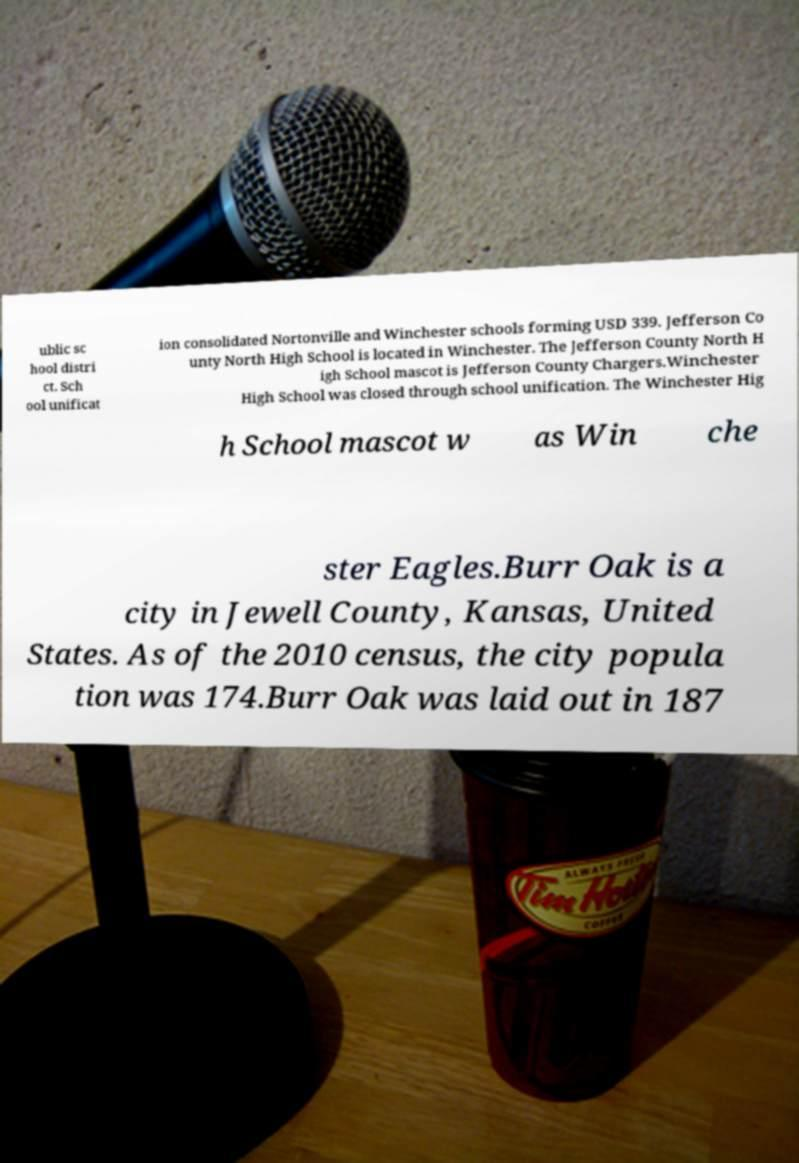What messages or text are displayed in this image? I need them in a readable, typed format. ublic sc hool distri ct. Sch ool unificat ion consolidated Nortonville and Winchester schools forming USD 339. Jefferson Co unty North High School is located in Winchester. The Jefferson County North H igh School mascot is Jefferson County Chargers.Winchester High School was closed through school unification. The Winchester Hig h School mascot w as Win che ster Eagles.Burr Oak is a city in Jewell County, Kansas, United States. As of the 2010 census, the city popula tion was 174.Burr Oak was laid out in 187 